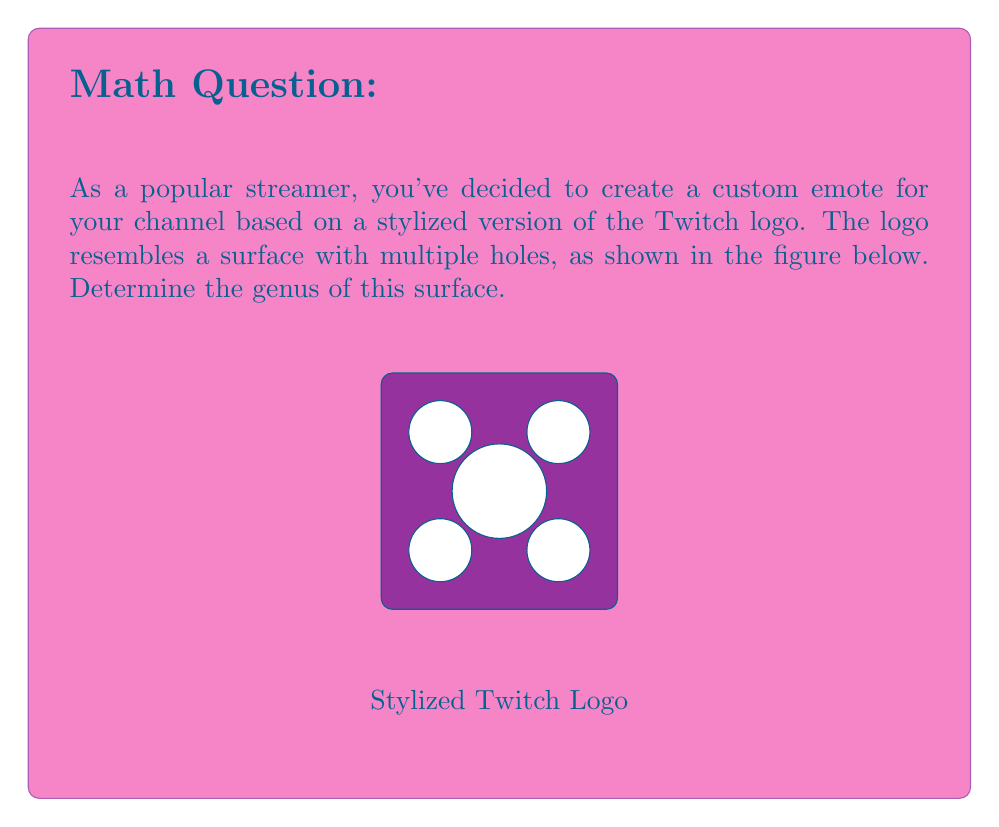Solve this math problem. To find the genus of this surface, we need to follow these steps:

1) First, recall that the genus of a surface is the number of holes or "handles" it has. It's a topological invariant that remains unchanged under continuous deformations.

2) In this stylized Twitch logo, we can see that there are 5 distinct holes:
   - Four smaller holes in the corners
   - One larger hole in the center

3) Each of these holes contributes to the genus of the surface. In topology, we consider a surface with $n$ holes to have a genus of $n$.

4) Therefore, we can directly count the number of holes to determine the genus.

5) Mathematically, we can express the genus $g$ as:

   $$g = \text{number of holes} = 5$$

6) It's worth noting that this surface is topologically equivalent to a sphere with 5 handles attached, which is often denoted as $\#_5(T^2)$ in topology, where $T^2$ represents a torus (a surface of genus 1).

7) The Euler characteristic $\chi$ of this surface can be calculated using the formula:

   $$\chi = 2 - 2g = 2 - 2(5) = -8$$

This negative Euler characteristic confirms that we're dealing with a higher genus surface.
Answer: $5$ 